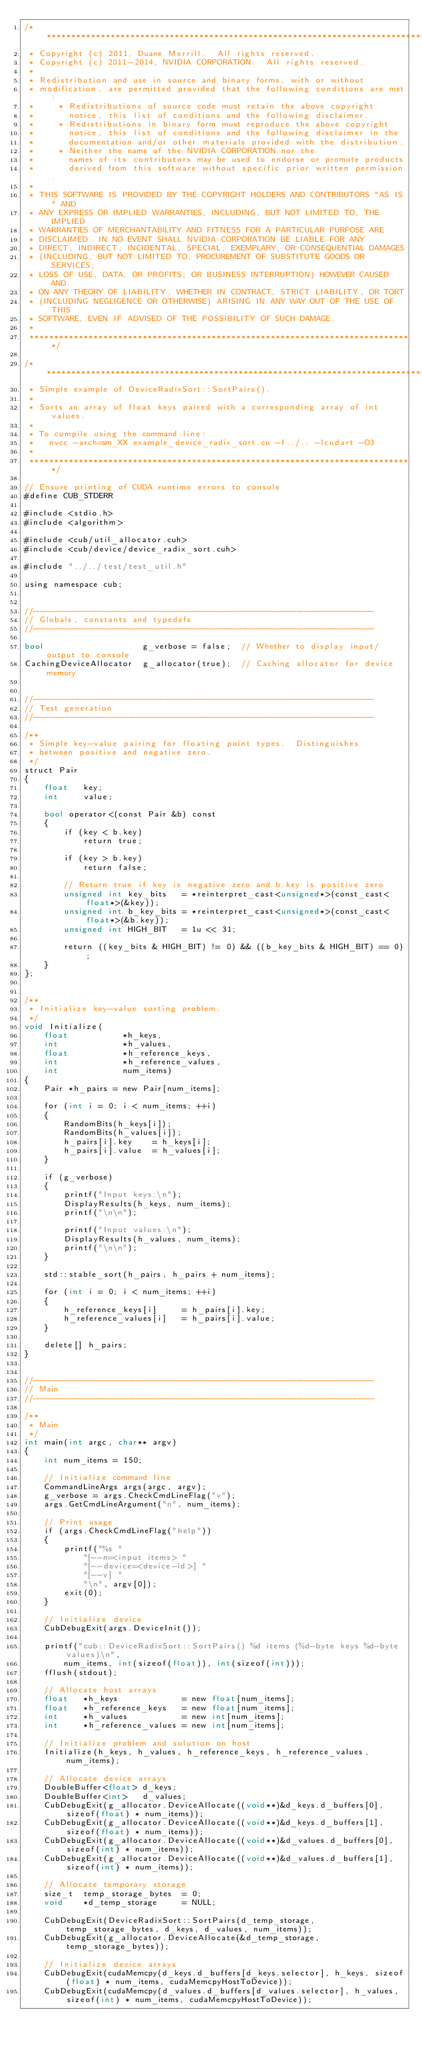<code> <loc_0><loc_0><loc_500><loc_500><_Cuda_>/******************************************************************************
 * Copyright (c) 2011, Duane Merrill.  All rights reserved.
 * Copyright (c) 2011-2014, NVIDIA CORPORATION.  All rights reserved.
 *
 * Redistribution and use in source and binary forms, with or without
 * modification, are permitted provided that the following conditions are met:
 *     * Redistributions of source code must retain the above copyright
 *       notice, this list of conditions and the following disclaimer.
 *     * Redistributions in binary form must reproduce the above copyright
 *       notice, this list of conditions and the following disclaimer in the
 *       documentation and/or other materials provided with the distribution.
 *     * Neither the name of the NVIDIA CORPORATION nor the
 *       names of its contributors may be used to endorse or promote products
 *       derived from this software without specific prior written permission.
 *
 * THIS SOFTWARE IS PROVIDED BY THE COPYRIGHT HOLDERS AND CONTRIBUTORS "AS IS" AND
 * ANY EXPRESS OR IMPLIED WARRANTIES, INCLUDING, BUT NOT LIMITED TO, THE IMPLIED
 * WARRANTIES OF MERCHANTABILITY AND FITNESS FOR A PARTICULAR PURPOSE ARE
 * DISCLAIMED. IN NO EVENT SHALL NVIDIA CORPORATION BE LIABLE FOR ANY
 * DIRECT, INDIRECT, INCIDENTAL, SPECIAL, EXEMPLARY, OR CONSEQUENTIAL DAMAGES
 * (INCLUDING, BUT NOT LIMITED TO, PROCUREMENT OF SUBSTITUTE GOODS OR SERVICES;
 * LOSS OF USE, DATA, OR PROFITS; OR BUSINESS INTERRUPTION) HOWEVER CAUSED AND
 * ON ANY THEORY OF LIABILITY, WHETHER IN CONTRACT, STRICT LIABILITY, OR TORT
 * (INCLUDING NEGLIGENCE OR OTHERWISE) ARISING IN ANY WAY OUT OF THE USE OF THIS
 * SOFTWARE, EVEN IF ADVISED OF THE POSSIBILITY OF SUCH DAMAGE.
 *
 ******************************************************************************/

/******************************************************************************
 * Simple example of DeviceRadixSort::SortPairs().
 *
 * Sorts an array of float keys paired with a corresponding array of int values.
 *
 * To compile using the command line:
 *   nvcc -arch=sm_XX example_device_radix_sort.cu -I../.. -lcudart -O3
 *
 ******************************************************************************/

// Ensure printing of CUDA runtime errors to console
#define CUB_STDERR

#include <stdio.h>
#include <algorithm>

#include <cub/util_allocator.cuh>
#include <cub/device/device_radix_sort.cuh>

#include "../../test/test_util.h"

using namespace cub;


//---------------------------------------------------------------------
// Globals, constants and typedefs
//---------------------------------------------------------------------

bool                    g_verbose = false;  // Whether to display input/output to console
CachingDeviceAllocator  g_allocator(true);  // Caching allocator for device memory


//---------------------------------------------------------------------
// Test generation
//---------------------------------------------------------------------

/**
 * Simple key-value pairing for floating point types.  Distinguishes
 * between positive and negative zero.
 */
struct Pair
{
    float   key;
    int     value;

    bool operator<(const Pair &b) const
    {
        if (key < b.key)
            return true;

        if (key > b.key)
            return false;

        // Return true if key is negative zero and b.key is positive zero
        unsigned int key_bits   = *reinterpret_cast<unsigned*>(const_cast<float*>(&key));
        unsigned int b_key_bits = *reinterpret_cast<unsigned*>(const_cast<float*>(&b.key));
        unsigned int HIGH_BIT   = 1u << 31;

        return ((key_bits & HIGH_BIT) != 0) && ((b_key_bits & HIGH_BIT) == 0);
    }
};


/**
 * Initialize key-value sorting problem.
 */
void Initialize(
    float           *h_keys,
    int             *h_values,
    float           *h_reference_keys,
    int             *h_reference_values,
    int             num_items)
{
    Pair *h_pairs = new Pair[num_items];

    for (int i = 0; i < num_items; ++i)
    {
        RandomBits(h_keys[i]);
        RandomBits(h_values[i]);
        h_pairs[i].key    = h_keys[i];
        h_pairs[i].value  = h_values[i];
    }

    if (g_verbose)
    {
        printf("Input keys:\n");
        DisplayResults(h_keys, num_items);
        printf("\n\n");

        printf("Input values:\n");
        DisplayResults(h_values, num_items);
        printf("\n\n");
    }

    std::stable_sort(h_pairs, h_pairs + num_items);

    for (int i = 0; i < num_items; ++i)
    {
        h_reference_keys[i]     = h_pairs[i].key;
        h_reference_values[i]   = h_pairs[i].value;
    }

    delete[] h_pairs;
}


//---------------------------------------------------------------------
// Main
//---------------------------------------------------------------------

/**
 * Main
 */
int main(int argc, char** argv)
{
    int num_items = 150;

    // Initialize command line
    CommandLineArgs args(argc, argv);
    g_verbose = args.CheckCmdLineFlag("v");
    args.GetCmdLineArgument("n", num_items);

    // Print usage
    if (args.CheckCmdLineFlag("help"))
    {
        printf("%s "
            "[--n=<input items> "
            "[--device=<device-id>] "
            "[--v] "
            "\n", argv[0]);
        exit(0);
    }

    // Initialize device
    CubDebugExit(args.DeviceInit());

    printf("cub::DeviceRadixSort::SortPairs() %d items (%d-byte keys %d-byte values)\n",
        num_items, int(sizeof(float)), int(sizeof(int)));
    fflush(stdout);

    // Allocate host arrays
    float   *h_keys             = new float[num_items];
    float   *h_reference_keys   = new float[num_items];
    int     *h_values           = new int[num_items];
    int     *h_reference_values = new int[num_items];

    // Initialize problem and solution on host
    Initialize(h_keys, h_values, h_reference_keys, h_reference_values, num_items);

    // Allocate device arrays
    DoubleBuffer<float> d_keys;
    DoubleBuffer<int>   d_values;
    CubDebugExit(g_allocator.DeviceAllocate((void**)&d_keys.d_buffers[0], sizeof(float) * num_items));
    CubDebugExit(g_allocator.DeviceAllocate((void**)&d_keys.d_buffers[1], sizeof(float) * num_items));
    CubDebugExit(g_allocator.DeviceAllocate((void**)&d_values.d_buffers[0], sizeof(int) * num_items));
    CubDebugExit(g_allocator.DeviceAllocate((void**)&d_values.d_buffers[1], sizeof(int) * num_items));

    // Allocate temporary storage
    size_t  temp_storage_bytes  = 0;
    void    *d_temp_storage     = NULL;

    CubDebugExit(DeviceRadixSort::SortPairs(d_temp_storage, temp_storage_bytes, d_keys, d_values, num_items));
    CubDebugExit(g_allocator.DeviceAllocate(&d_temp_storage, temp_storage_bytes));

    // Initialize device arrays
    CubDebugExit(cudaMemcpy(d_keys.d_buffers[d_keys.selector], h_keys, sizeof(float) * num_items, cudaMemcpyHostToDevice));
    CubDebugExit(cudaMemcpy(d_values.d_buffers[d_values.selector], h_values, sizeof(int) * num_items, cudaMemcpyHostToDevice));
</code> 